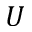<formula> <loc_0><loc_0><loc_500><loc_500>U</formula> 